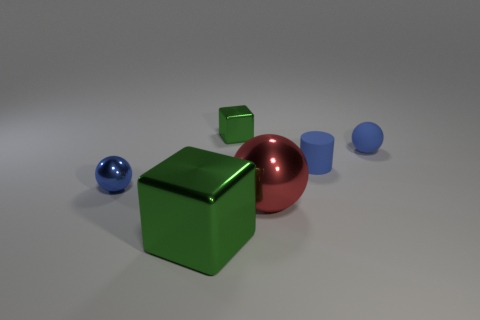How many blue balls must be subtracted to get 1 blue balls? 1 Subtract 2 green cubes. How many objects are left? 4 Subtract all cylinders. How many objects are left? 5 Subtract all yellow spheres. Subtract all gray cubes. How many spheres are left? 3 Subtract all brown cylinders. How many gray spheres are left? 0 Subtract all tiny green metal cubes. Subtract all small purple matte spheres. How many objects are left? 5 Add 1 blocks. How many blocks are left? 3 Add 5 gray metallic things. How many gray metallic things exist? 5 Add 3 matte cylinders. How many objects exist? 9 Subtract all red spheres. How many spheres are left? 2 